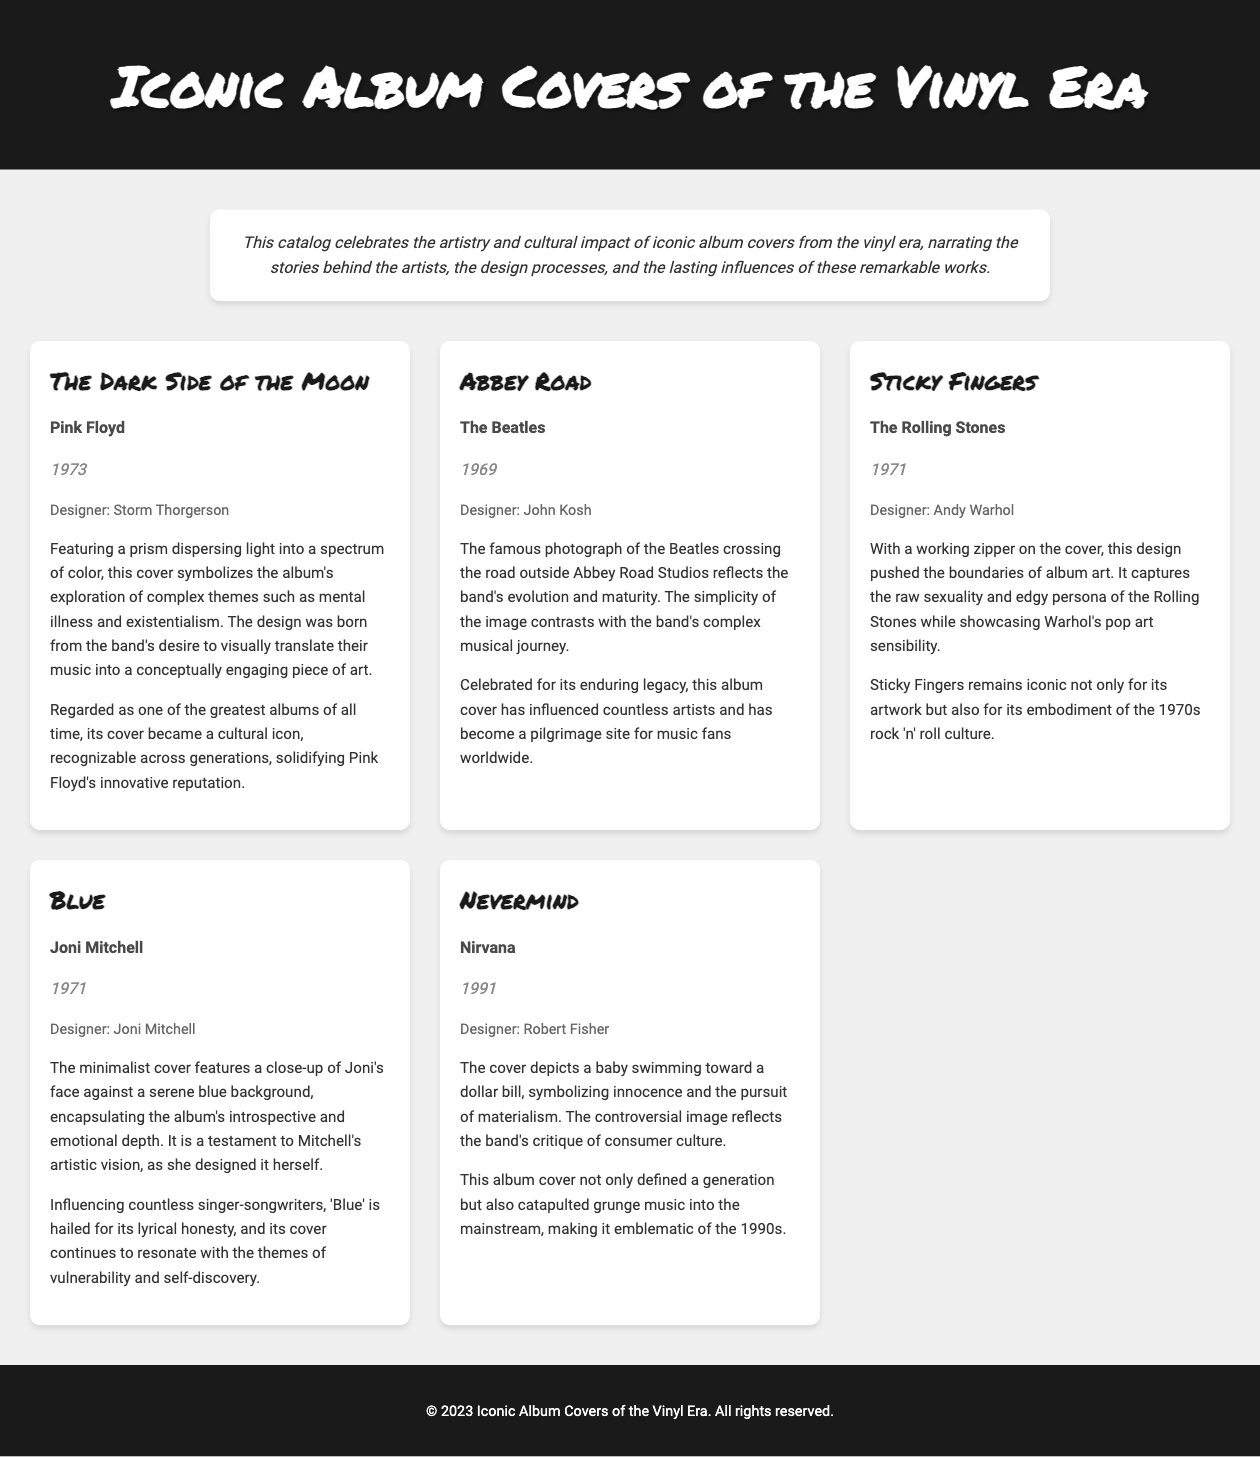what is the title of the album by Pink Floyd? The title of the album by Pink Floyd is mentioned directly in the document.
Answer: The Dark Side of the Moon who designed the cover of Abbey Road? The document specifies the designer of Abbey Road's cover.
Answer: John Kosh what year was Sticky Fingers released? The release year of the Sticky Fingers album is clearly stated in the document.
Answer: 1971 which artist designed their own cover for Blue? The document indicates that the artist designed their own cover, leading to this answer.
Answer: Joni Mitchell what visual element is significant on the cover of Sticky Fingers? The description highlights a unique feature of the Sticky Fingers cover.
Answer: A working zipper what is depicted on the cover of Nevermind? The document describes the imagery present on the Nevermind album cover.
Answer: A baby swimming toward a dollar bill which album is considered emblematic of the 1990s? The document mentions an album defining a generation, indicative of its cultural significance.
Answer: Nevermind what theme does the cover of The Dark Side of the Moon symbolize? The document elaborates on the symbolic meaning of The Dark Side of the Moon cover.
Answer: Mental illness and existentialism how has the Abbey Road cover influenced music culture? The impact of the Abbey Road album cover is discussed in context.
Answer: Influenced countless artists and became a pilgrimage site 